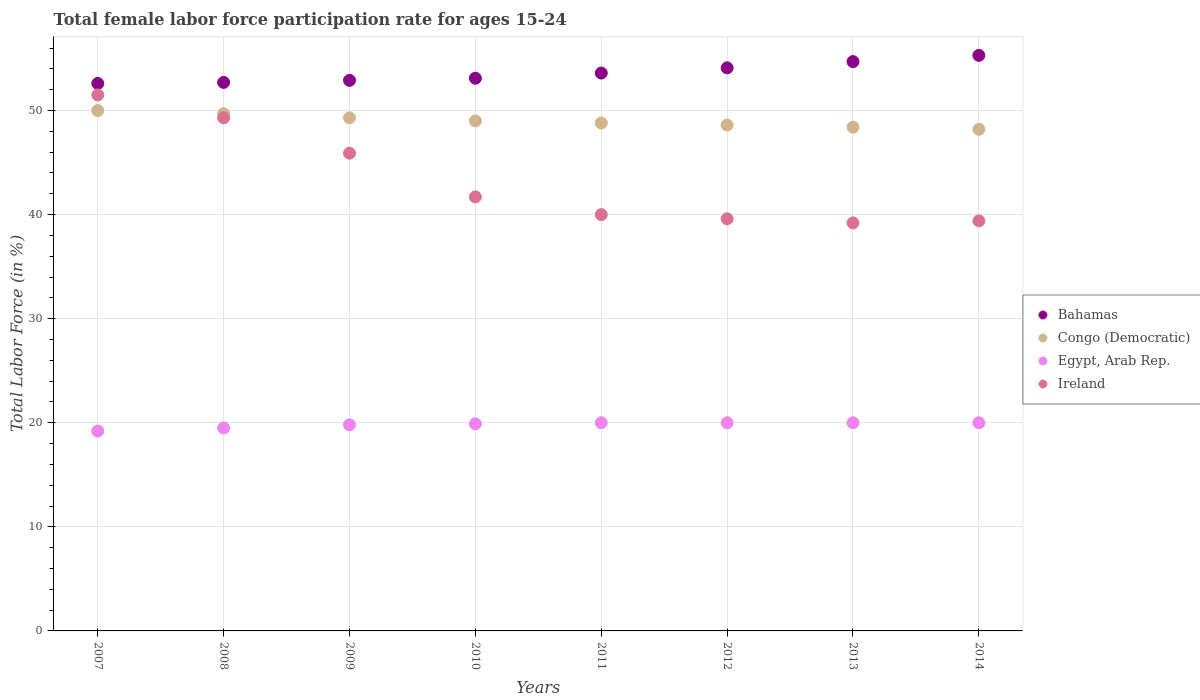What is the female labor force participation rate in Ireland in 2008?
Your response must be concise. 49.3. Across all years, what is the minimum female labor force participation rate in Bahamas?
Offer a very short reply. 52.6. What is the total female labor force participation rate in Bahamas in the graph?
Your answer should be very brief. 429. What is the difference between the female labor force participation rate in Congo (Democratic) in 2009 and that in 2014?
Your answer should be very brief. 1.1. What is the difference between the female labor force participation rate in Congo (Democratic) in 2011 and the female labor force participation rate in Egypt, Arab Rep. in 2008?
Give a very brief answer. 29.3. What is the average female labor force participation rate in Egypt, Arab Rep. per year?
Offer a very short reply. 19.8. In the year 2010, what is the difference between the female labor force participation rate in Bahamas and female labor force participation rate in Congo (Democratic)?
Keep it short and to the point. 4.1. In how many years, is the female labor force participation rate in Ireland greater than 28 %?
Provide a short and direct response. 8. What is the ratio of the female labor force participation rate in Egypt, Arab Rep. in 2009 to that in 2011?
Offer a terse response. 0.99. What is the difference between the highest and the second highest female labor force participation rate in Ireland?
Offer a very short reply. 2.2. What is the difference between the highest and the lowest female labor force participation rate in Egypt, Arab Rep.?
Offer a terse response. 0.8. Is it the case that in every year, the sum of the female labor force participation rate in Bahamas and female labor force participation rate in Egypt, Arab Rep.  is greater than the sum of female labor force participation rate in Congo (Democratic) and female labor force participation rate in Ireland?
Offer a terse response. No. Is it the case that in every year, the sum of the female labor force participation rate in Egypt, Arab Rep. and female labor force participation rate in Ireland  is greater than the female labor force participation rate in Bahamas?
Your answer should be very brief. Yes. Are the values on the major ticks of Y-axis written in scientific E-notation?
Ensure brevity in your answer.  No. What is the title of the graph?
Your response must be concise. Total female labor force participation rate for ages 15-24. What is the label or title of the X-axis?
Ensure brevity in your answer.  Years. What is the label or title of the Y-axis?
Your answer should be compact. Total Labor Force (in %). What is the Total Labor Force (in %) of Bahamas in 2007?
Make the answer very short. 52.6. What is the Total Labor Force (in %) in Egypt, Arab Rep. in 2007?
Keep it short and to the point. 19.2. What is the Total Labor Force (in %) of Ireland in 2007?
Your answer should be compact. 51.5. What is the Total Labor Force (in %) of Bahamas in 2008?
Your answer should be compact. 52.7. What is the Total Labor Force (in %) of Congo (Democratic) in 2008?
Offer a very short reply. 49.7. What is the Total Labor Force (in %) in Ireland in 2008?
Ensure brevity in your answer.  49.3. What is the Total Labor Force (in %) of Bahamas in 2009?
Provide a succinct answer. 52.9. What is the Total Labor Force (in %) of Congo (Democratic) in 2009?
Your answer should be compact. 49.3. What is the Total Labor Force (in %) in Egypt, Arab Rep. in 2009?
Your answer should be compact. 19.8. What is the Total Labor Force (in %) in Ireland in 2009?
Your answer should be compact. 45.9. What is the Total Labor Force (in %) in Bahamas in 2010?
Your answer should be compact. 53.1. What is the Total Labor Force (in %) of Egypt, Arab Rep. in 2010?
Make the answer very short. 19.9. What is the Total Labor Force (in %) in Ireland in 2010?
Make the answer very short. 41.7. What is the Total Labor Force (in %) of Bahamas in 2011?
Provide a succinct answer. 53.6. What is the Total Labor Force (in %) of Congo (Democratic) in 2011?
Give a very brief answer. 48.8. What is the Total Labor Force (in %) of Egypt, Arab Rep. in 2011?
Give a very brief answer. 20. What is the Total Labor Force (in %) of Ireland in 2011?
Give a very brief answer. 40. What is the Total Labor Force (in %) of Bahamas in 2012?
Ensure brevity in your answer.  54.1. What is the Total Labor Force (in %) in Congo (Democratic) in 2012?
Your response must be concise. 48.6. What is the Total Labor Force (in %) of Ireland in 2012?
Make the answer very short. 39.6. What is the Total Labor Force (in %) of Bahamas in 2013?
Give a very brief answer. 54.7. What is the Total Labor Force (in %) of Congo (Democratic) in 2013?
Ensure brevity in your answer.  48.4. What is the Total Labor Force (in %) in Egypt, Arab Rep. in 2013?
Make the answer very short. 20. What is the Total Labor Force (in %) in Ireland in 2013?
Keep it short and to the point. 39.2. What is the Total Labor Force (in %) of Bahamas in 2014?
Give a very brief answer. 55.3. What is the Total Labor Force (in %) of Congo (Democratic) in 2014?
Make the answer very short. 48.2. What is the Total Labor Force (in %) of Egypt, Arab Rep. in 2014?
Provide a succinct answer. 20. What is the Total Labor Force (in %) of Ireland in 2014?
Offer a terse response. 39.4. Across all years, what is the maximum Total Labor Force (in %) of Bahamas?
Provide a succinct answer. 55.3. Across all years, what is the maximum Total Labor Force (in %) in Ireland?
Your answer should be compact. 51.5. Across all years, what is the minimum Total Labor Force (in %) of Bahamas?
Provide a short and direct response. 52.6. Across all years, what is the minimum Total Labor Force (in %) of Congo (Democratic)?
Your answer should be compact. 48.2. Across all years, what is the minimum Total Labor Force (in %) in Egypt, Arab Rep.?
Your answer should be very brief. 19.2. Across all years, what is the minimum Total Labor Force (in %) in Ireland?
Make the answer very short. 39.2. What is the total Total Labor Force (in %) of Bahamas in the graph?
Keep it short and to the point. 429. What is the total Total Labor Force (in %) in Congo (Democratic) in the graph?
Offer a terse response. 392. What is the total Total Labor Force (in %) of Egypt, Arab Rep. in the graph?
Keep it short and to the point. 158.4. What is the total Total Labor Force (in %) in Ireland in the graph?
Your answer should be very brief. 346.6. What is the difference between the Total Labor Force (in %) in Ireland in 2007 and that in 2008?
Offer a terse response. 2.2. What is the difference between the Total Labor Force (in %) of Bahamas in 2007 and that in 2009?
Give a very brief answer. -0.3. What is the difference between the Total Labor Force (in %) of Ireland in 2007 and that in 2009?
Keep it short and to the point. 5.6. What is the difference between the Total Labor Force (in %) in Bahamas in 2007 and that in 2010?
Provide a succinct answer. -0.5. What is the difference between the Total Labor Force (in %) of Egypt, Arab Rep. in 2007 and that in 2010?
Keep it short and to the point. -0.7. What is the difference between the Total Labor Force (in %) of Bahamas in 2007 and that in 2011?
Your answer should be compact. -1. What is the difference between the Total Labor Force (in %) of Congo (Democratic) in 2007 and that in 2011?
Your response must be concise. 1.2. What is the difference between the Total Labor Force (in %) in Congo (Democratic) in 2007 and that in 2012?
Ensure brevity in your answer.  1.4. What is the difference between the Total Labor Force (in %) in Egypt, Arab Rep. in 2007 and that in 2012?
Offer a very short reply. -0.8. What is the difference between the Total Labor Force (in %) in Bahamas in 2007 and that in 2013?
Ensure brevity in your answer.  -2.1. What is the difference between the Total Labor Force (in %) of Egypt, Arab Rep. in 2007 and that in 2013?
Your answer should be compact. -0.8. What is the difference between the Total Labor Force (in %) of Bahamas in 2007 and that in 2014?
Your answer should be compact. -2.7. What is the difference between the Total Labor Force (in %) in Egypt, Arab Rep. in 2007 and that in 2014?
Offer a terse response. -0.8. What is the difference between the Total Labor Force (in %) in Ireland in 2007 and that in 2014?
Provide a short and direct response. 12.1. What is the difference between the Total Labor Force (in %) of Congo (Democratic) in 2008 and that in 2009?
Ensure brevity in your answer.  0.4. What is the difference between the Total Labor Force (in %) in Egypt, Arab Rep. in 2008 and that in 2009?
Offer a very short reply. -0.3. What is the difference between the Total Labor Force (in %) of Ireland in 2008 and that in 2009?
Your answer should be very brief. 3.4. What is the difference between the Total Labor Force (in %) in Ireland in 2008 and that in 2010?
Ensure brevity in your answer.  7.6. What is the difference between the Total Labor Force (in %) of Bahamas in 2008 and that in 2011?
Keep it short and to the point. -0.9. What is the difference between the Total Labor Force (in %) in Egypt, Arab Rep. in 2008 and that in 2011?
Provide a succinct answer. -0.5. What is the difference between the Total Labor Force (in %) of Bahamas in 2008 and that in 2013?
Your answer should be compact. -2. What is the difference between the Total Labor Force (in %) in Congo (Democratic) in 2008 and that in 2013?
Your answer should be very brief. 1.3. What is the difference between the Total Labor Force (in %) in Egypt, Arab Rep. in 2008 and that in 2013?
Offer a very short reply. -0.5. What is the difference between the Total Labor Force (in %) in Ireland in 2008 and that in 2013?
Your response must be concise. 10.1. What is the difference between the Total Labor Force (in %) in Egypt, Arab Rep. in 2008 and that in 2014?
Provide a succinct answer. -0.5. What is the difference between the Total Labor Force (in %) of Ireland in 2008 and that in 2014?
Provide a succinct answer. 9.9. What is the difference between the Total Labor Force (in %) in Bahamas in 2009 and that in 2010?
Your answer should be very brief. -0.2. What is the difference between the Total Labor Force (in %) in Congo (Democratic) in 2009 and that in 2010?
Your answer should be compact. 0.3. What is the difference between the Total Labor Force (in %) of Egypt, Arab Rep. in 2009 and that in 2010?
Ensure brevity in your answer.  -0.1. What is the difference between the Total Labor Force (in %) of Ireland in 2009 and that in 2010?
Provide a succinct answer. 4.2. What is the difference between the Total Labor Force (in %) in Bahamas in 2009 and that in 2011?
Make the answer very short. -0.7. What is the difference between the Total Labor Force (in %) in Congo (Democratic) in 2009 and that in 2012?
Ensure brevity in your answer.  0.7. What is the difference between the Total Labor Force (in %) in Bahamas in 2009 and that in 2013?
Your answer should be compact. -1.8. What is the difference between the Total Labor Force (in %) in Congo (Democratic) in 2009 and that in 2013?
Your answer should be very brief. 0.9. What is the difference between the Total Labor Force (in %) in Bahamas in 2009 and that in 2014?
Your response must be concise. -2.4. What is the difference between the Total Labor Force (in %) in Congo (Democratic) in 2009 and that in 2014?
Provide a short and direct response. 1.1. What is the difference between the Total Labor Force (in %) in Ireland in 2009 and that in 2014?
Ensure brevity in your answer.  6.5. What is the difference between the Total Labor Force (in %) in Bahamas in 2010 and that in 2011?
Your answer should be very brief. -0.5. What is the difference between the Total Labor Force (in %) of Congo (Democratic) in 2010 and that in 2011?
Provide a short and direct response. 0.2. What is the difference between the Total Labor Force (in %) of Egypt, Arab Rep. in 2010 and that in 2011?
Ensure brevity in your answer.  -0.1. What is the difference between the Total Labor Force (in %) of Ireland in 2010 and that in 2011?
Give a very brief answer. 1.7. What is the difference between the Total Labor Force (in %) of Bahamas in 2010 and that in 2012?
Your response must be concise. -1. What is the difference between the Total Labor Force (in %) of Congo (Democratic) in 2010 and that in 2012?
Ensure brevity in your answer.  0.4. What is the difference between the Total Labor Force (in %) of Egypt, Arab Rep. in 2010 and that in 2012?
Your answer should be very brief. -0.1. What is the difference between the Total Labor Force (in %) in Ireland in 2010 and that in 2012?
Give a very brief answer. 2.1. What is the difference between the Total Labor Force (in %) of Bahamas in 2010 and that in 2013?
Provide a short and direct response. -1.6. What is the difference between the Total Labor Force (in %) in Congo (Democratic) in 2010 and that in 2013?
Ensure brevity in your answer.  0.6. What is the difference between the Total Labor Force (in %) of Ireland in 2010 and that in 2013?
Provide a succinct answer. 2.5. What is the difference between the Total Labor Force (in %) in Congo (Democratic) in 2010 and that in 2014?
Your response must be concise. 0.8. What is the difference between the Total Labor Force (in %) of Egypt, Arab Rep. in 2010 and that in 2014?
Ensure brevity in your answer.  -0.1. What is the difference between the Total Labor Force (in %) in Ireland in 2010 and that in 2014?
Provide a succinct answer. 2.3. What is the difference between the Total Labor Force (in %) of Congo (Democratic) in 2011 and that in 2012?
Ensure brevity in your answer.  0.2. What is the difference between the Total Labor Force (in %) of Congo (Democratic) in 2011 and that in 2013?
Your response must be concise. 0.4. What is the difference between the Total Labor Force (in %) of Egypt, Arab Rep. in 2011 and that in 2013?
Offer a very short reply. 0. What is the difference between the Total Labor Force (in %) of Ireland in 2011 and that in 2013?
Make the answer very short. 0.8. What is the difference between the Total Labor Force (in %) in Egypt, Arab Rep. in 2011 and that in 2014?
Keep it short and to the point. 0. What is the difference between the Total Labor Force (in %) in Bahamas in 2012 and that in 2013?
Make the answer very short. -0.6. What is the difference between the Total Labor Force (in %) in Egypt, Arab Rep. in 2012 and that in 2013?
Your response must be concise. 0. What is the difference between the Total Labor Force (in %) in Ireland in 2012 and that in 2013?
Offer a terse response. 0.4. What is the difference between the Total Labor Force (in %) of Congo (Democratic) in 2012 and that in 2014?
Give a very brief answer. 0.4. What is the difference between the Total Labor Force (in %) in Ireland in 2012 and that in 2014?
Provide a short and direct response. 0.2. What is the difference between the Total Labor Force (in %) in Congo (Democratic) in 2013 and that in 2014?
Make the answer very short. 0.2. What is the difference between the Total Labor Force (in %) of Egypt, Arab Rep. in 2013 and that in 2014?
Make the answer very short. 0. What is the difference between the Total Labor Force (in %) in Ireland in 2013 and that in 2014?
Provide a succinct answer. -0.2. What is the difference between the Total Labor Force (in %) of Bahamas in 2007 and the Total Labor Force (in %) of Congo (Democratic) in 2008?
Make the answer very short. 2.9. What is the difference between the Total Labor Force (in %) in Bahamas in 2007 and the Total Labor Force (in %) in Egypt, Arab Rep. in 2008?
Keep it short and to the point. 33.1. What is the difference between the Total Labor Force (in %) in Congo (Democratic) in 2007 and the Total Labor Force (in %) in Egypt, Arab Rep. in 2008?
Your answer should be very brief. 30.5. What is the difference between the Total Labor Force (in %) in Egypt, Arab Rep. in 2007 and the Total Labor Force (in %) in Ireland in 2008?
Keep it short and to the point. -30.1. What is the difference between the Total Labor Force (in %) of Bahamas in 2007 and the Total Labor Force (in %) of Congo (Democratic) in 2009?
Your answer should be very brief. 3.3. What is the difference between the Total Labor Force (in %) of Bahamas in 2007 and the Total Labor Force (in %) of Egypt, Arab Rep. in 2009?
Your answer should be very brief. 32.8. What is the difference between the Total Labor Force (in %) of Bahamas in 2007 and the Total Labor Force (in %) of Ireland in 2009?
Ensure brevity in your answer.  6.7. What is the difference between the Total Labor Force (in %) in Congo (Democratic) in 2007 and the Total Labor Force (in %) in Egypt, Arab Rep. in 2009?
Your answer should be compact. 30.2. What is the difference between the Total Labor Force (in %) in Egypt, Arab Rep. in 2007 and the Total Labor Force (in %) in Ireland in 2009?
Offer a very short reply. -26.7. What is the difference between the Total Labor Force (in %) in Bahamas in 2007 and the Total Labor Force (in %) in Egypt, Arab Rep. in 2010?
Make the answer very short. 32.7. What is the difference between the Total Labor Force (in %) of Congo (Democratic) in 2007 and the Total Labor Force (in %) of Egypt, Arab Rep. in 2010?
Your answer should be compact. 30.1. What is the difference between the Total Labor Force (in %) of Congo (Democratic) in 2007 and the Total Labor Force (in %) of Ireland in 2010?
Your response must be concise. 8.3. What is the difference between the Total Labor Force (in %) in Egypt, Arab Rep. in 2007 and the Total Labor Force (in %) in Ireland in 2010?
Offer a very short reply. -22.5. What is the difference between the Total Labor Force (in %) in Bahamas in 2007 and the Total Labor Force (in %) in Egypt, Arab Rep. in 2011?
Make the answer very short. 32.6. What is the difference between the Total Labor Force (in %) in Egypt, Arab Rep. in 2007 and the Total Labor Force (in %) in Ireland in 2011?
Offer a terse response. -20.8. What is the difference between the Total Labor Force (in %) in Bahamas in 2007 and the Total Labor Force (in %) in Egypt, Arab Rep. in 2012?
Ensure brevity in your answer.  32.6. What is the difference between the Total Labor Force (in %) in Bahamas in 2007 and the Total Labor Force (in %) in Ireland in 2012?
Ensure brevity in your answer.  13. What is the difference between the Total Labor Force (in %) in Egypt, Arab Rep. in 2007 and the Total Labor Force (in %) in Ireland in 2012?
Your response must be concise. -20.4. What is the difference between the Total Labor Force (in %) of Bahamas in 2007 and the Total Labor Force (in %) of Congo (Democratic) in 2013?
Provide a succinct answer. 4.2. What is the difference between the Total Labor Force (in %) of Bahamas in 2007 and the Total Labor Force (in %) of Egypt, Arab Rep. in 2013?
Offer a very short reply. 32.6. What is the difference between the Total Labor Force (in %) in Bahamas in 2007 and the Total Labor Force (in %) in Ireland in 2013?
Offer a very short reply. 13.4. What is the difference between the Total Labor Force (in %) of Bahamas in 2007 and the Total Labor Force (in %) of Egypt, Arab Rep. in 2014?
Ensure brevity in your answer.  32.6. What is the difference between the Total Labor Force (in %) in Egypt, Arab Rep. in 2007 and the Total Labor Force (in %) in Ireland in 2014?
Your answer should be compact. -20.2. What is the difference between the Total Labor Force (in %) in Bahamas in 2008 and the Total Labor Force (in %) in Egypt, Arab Rep. in 2009?
Provide a succinct answer. 32.9. What is the difference between the Total Labor Force (in %) of Bahamas in 2008 and the Total Labor Force (in %) of Ireland in 2009?
Keep it short and to the point. 6.8. What is the difference between the Total Labor Force (in %) of Congo (Democratic) in 2008 and the Total Labor Force (in %) of Egypt, Arab Rep. in 2009?
Provide a short and direct response. 29.9. What is the difference between the Total Labor Force (in %) in Egypt, Arab Rep. in 2008 and the Total Labor Force (in %) in Ireland in 2009?
Provide a short and direct response. -26.4. What is the difference between the Total Labor Force (in %) in Bahamas in 2008 and the Total Labor Force (in %) in Congo (Democratic) in 2010?
Provide a succinct answer. 3.7. What is the difference between the Total Labor Force (in %) of Bahamas in 2008 and the Total Labor Force (in %) of Egypt, Arab Rep. in 2010?
Give a very brief answer. 32.8. What is the difference between the Total Labor Force (in %) of Bahamas in 2008 and the Total Labor Force (in %) of Ireland in 2010?
Ensure brevity in your answer.  11. What is the difference between the Total Labor Force (in %) of Congo (Democratic) in 2008 and the Total Labor Force (in %) of Egypt, Arab Rep. in 2010?
Your answer should be very brief. 29.8. What is the difference between the Total Labor Force (in %) of Congo (Democratic) in 2008 and the Total Labor Force (in %) of Ireland in 2010?
Make the answer very short. 8. What is the difference between the Total Labor Force (in %) of Egypt, Arab Rep. in 2008 and the Total Labor Force (in %) of Ireland in 2010?
Make the answer very short. -22.2. What is the difference between the Total Labor Force (in %) of Bahamas in 2008 and the Total Labor Force (in %) of Congo (Democratic) in 2011?
Offer a terse response. 3.9. What is the difference between the Total Labor Force (in %) of Bahamas in 2008 and the Total Labor Force (in %) of Egypt, Arab Rep. in 2011?
Make the answer very short. 32.7. What is the difference between the Total Labor Force (in %) in Congo (Democratic) in 2008 and the Total Labor Force (in %) in Egypt, Arab Rep. in 2011?
Ensure brevity in your answer.  29.7. What is the difference between the Total Labor Force (in %) in Egypt, Arab Rep. in 2008 and the Total Labor Force (in %) in Ireland in 2011?
Offer a very short reply. -20.5. What is the difference between the Total Labor Force (in %) in Bahamas in 2008 and the Total Labor Force (in %) in Congo (Democratic) in 2012?
Provide a succinct answer. 4.1. What is the difference between the Total Labor Force (in %) in Bahamas in 2008 and the Total Labor Force (in %) in Egypt, Arab Rep. in 2012?
Your response must be concise. 32.7. What is the difference between the Total Labor Force (in %) in Bahamas in 2008 and the Total Labor Force (in %) in Ireland in 2012?
Offer a terse response. 13.1. What is the difference between the Total Labor Force (in %) of Congo (Democratic) in 2008 and the Total Labor Force (in %) of Egypt, Arab Rep. in 2012?
Ensure brevity in your answer.  29.7. What is the difference between the Total Labor Force (in %) in Egypt, Arab Rep. in 2008 and the Total Labor Force (in %) in Ireland in 2012?
Keep it short and to the point. -20.1. What is the difference between the Total Labor Force (in %) of Bahamas in 2008 and the Total Labor Force (in %) of Egypt, Arab Rep. in 2013?
Make the answer very short. 32.7. What is the difference between the Total Labor Force (in %) of Bahamas in 2008 and the Total Labor Force (in %) of Ireland in 2013?
Ensure brevity in your answer.  13.5. What is the difference between the Total Labor Force (in %) of Congo (Democratic) in 2008 and the Total Labor Force (in %) of Egypt, Arab Rep. in 2013?
Make the answer very short. 29.7. What is the difference between the Total Labor Force (in %) of Egypt, Arab Rep. in 2008 and the Total Labor Force (in %) of Ireland in 2013?
Your answer should be very brief. -19.7. What is the difference between the Total Labor Force (in %) of Bahamas in 2008 and the Total Labor Force (in %) of Egypt, Arab Rep. in 2014?
Provide a short and direct response. 32.7. What is the difference between the Total Labor Force (in %) in Bahamas in 2008 and the Total Labor Force (in %) in Ireland in 2014?
Offer a terse response. 13.3. What is the difference between the Total Labor Force (in %) of Congo (Democratic) in 2008 and the Total Labor Force (in %) of Egypt, Arab Rep. in 2014?
Offer a very short reply. 29.7. What is the difference between the Total Labor Force (in %) in Egypt, Arab Rep. in 2008 and the Total Labor Force (in %) in Ireland in 2014?
Your answer should be very brief. -19.9. What is the difference between the Total Labor Force (in %) in Bahamas in 2009 and the Total Labor Force (in %) in Ireland in 2010?
Provide a short and direct response. 11.2. What is the difference between the Total Labor Force (in %) of Congo (Democratic) in 2009 and the Total Labor Force (in %) of Egypt, Arab Rep. in 2010?
Ensure brevity in your answer.  29.4. What is the difference between the Total Labor Force (in %) in Congo (Democratic) in 2009 and the Total Labor Force (in %) in Ireland in 2010?
Provide a short and direct response. 7.6. What is the difference between the Total Labor Force (in %) of Egypt, Arab Rep. in 2009 and the Total Labor Force (in %) of Ireland in 2010?
Give a very brief answer. -21.9. What is the difference between the Total Labor Force (in %) of Bahamas in 2009 and the Total Labor Force (in %) of Egypt, Arab Rep. in 2011?
Give a very brief answer. 32.9. What is the difference between the Total Labor Force (in %) of Congo (Democratic) in 2009 and the Total Labor Force (in %) of Egypt, Arab Rep. in 2011?
Provide a succinct answer. 29.3. What is the difference between the Total Labor Force (in %) of Congo (Democratic) in 2009 and the Total Labor Force (in %) of Ireland in 2011?
Provide a succinct answer. 9.3. What is the difference between the Total Labor Force (in %) in Egypt, Arab Rep. in 2009 and the Total Labor Force (in %) in Ireland in 2011?
Offer a terse response. -20.2. What is the difference between the Total Labor Force (in %) in Bahamas in 2009 and the Total Labor Force (in %) in Egypt, Arab Rep. in 2012?
Provide a short and direct response. 32.9. What is the difference between the Total Labor Force (in %) of Congo (Democratic) in 2009 and the Total Labor Force (in %) of Egypt, Arab Rep. in 2012?
Your answer should be very brief. 29.3. What is the difference between the Total Labor Force (in %) of Congo (Democratic) in 2009 and the Total Labor Force (in %) of Ireland in 2012?
Your answer should be very brief. 9.7. What is the difference between the Total Labor Force (in %) of Egypt, Arab Rep. in 2009 and the Total Labor Force (in %) of Ireland in 2012?
Provide a short and direct response. -19.8. What is the difference between the Total Labor Force (in %) in Bahamas in 2009 and the Total Labor Force (in %) in Egypt, Arab Rep. in 2013?
Your answer should be very brief. 32.9. What is the difference between the Total Labor Force (in %) of Congo (Democratic) in 2009 and the Total Labor Force (in %) of Egypt, Arab Rep. in 2013?
Your answer should be very brief. 29.3. What is the difference between the Total Labor Force (in %) in Egypt, Arab Rep. in 2009 and the Total Labor Force (in %) in Ireland in 2013?
Provide a short and direct response. -19.4. What is the difference between the Total Labor Force (in %) in Bahamas in 2009 and the Total Labor Force (in %) in Congo (Democratic) in 2014?
Provide a succinct answer. 4.7. What is the difference between the Total Labor Force (in %) of Bahamas in 2009 and the Total Labor Force (in %) of Egypt, Arab Rep. in 2014?
Your answer should be compact. 32.9. What is the difference between the Total Labor Force (in %) in Bahamas in 2009 and the Total Labor Force (in %) in Ireland in 2014?
Your response must be concise. 13.5. What is the difference between the Total Labor Force (in %) in Congo (Democratic) in 2009 and the Total Labor Force (in %) in Egypt, Arab Rep. in 2014?
Your answer should be very brief. 29.3. What is the difference between the Total Labor Force (in %) in Egypt, Arab Rep. in 2009 and the Total Labor Force (in %) in Ireland in 2014?
Give a very brief answer. -19.6. What is the difference between the Total Labor Force (in %) of Bahamas in 2010 and the Total Labor Force (in %) of Egypt, Arab Rep. in 2011?
Keep it short and to the point. 33.1. What is the difference between the Total Labor Force (in %) in Congo (Democratic) in 2010 and the Total Labor Force (in %) in Ireland in 2011?
Your response must be concise. 9. What is the difference between the Total Labor Force (in %) in Egypt, Arab Rep. in 2010 and the Total Labor Force (in %) in Ireland in 2011?
Provide a succinct answer. -20.1. What is the difference between the Total Labor Force (in %) of Bahamas in 2010 and the Total Labor Force (in %) of Egypt, Arab Rep. in 2012?
Provide a succinct answer. 33.1. What is the difference between the Total Labor Force (in %) of Bahamas in 2010 and the Total Labor Force (in %) of Ireland in 2012?
Offer a terse response. 13.5. What is the difference between the Total Labor Force (in %) of Congo (Democratic) in 2010 and the Total Labor Force (in %) of Egypt, Arab Rep. in 2012?
Make the answer very short. 29. What is the difference between the Total Labor Force (in %) in Congo (Democratic) in 2010 and the Total Labor Force (in %) in Ireland in 2012?
Provide a succinct answer. 9.4. What is the difference between the Total Labor Force (in %) in Egypt, Arab Rep. in 2010 and the Total Labor Force (in %) in Ireland in 2012?
Offer a terse response. -19.7. What is the difference between the Total Labor Force (in %) of Bahamas in 2010 and the Total Labor Force (in %) of Congo (Democratic) in 2013?
Keep it short and to the point. 4.7. What is the difference between the Total Labor Force (in %) of Bahamas in 2010 and the Total Labor Force (in %) of Egypt, Arab Rep. in 2013?
Your response must be concise. 33.1. What is the difference between the Total Labor Force (in %) in Bahamas in 2010 and the Total Labor Force (in %) in Ireland in 2013?
Your answer should be compact. 13.9. What is the difference between the Total Labor Force (in %) in Congo (Democratic) in 2010 and the Total Labor Force (in %) in Egypt, Arab Rep. in 2013?
Offer a very short reply. 29. What is the difference between the Total Labor Force (in %) in Egypt, Arab Rep. in 2010 and the Total Labor Force (in %) in Ireland in 2013?
Your answer should be compact. -19.3. What is the difference between the Total Labor Force (in %) in Bahamas in 2010 and the Total Labor Force (in %) in Egypt, Arab Rep. in 2014?
Offer a terse response. 33.1. What is the difference between the Total Labor Force (in %) of Bahamas in 2010 and the Total Labor Force (in %) of Ireland in 2014?
Provide a short and direct response. 13.7. What is the difference between the Total Labor Force (in %) of Congo (Democratic) in 2010 and the Total Labor Force (in %) of Ireland in 2014?
Provide a short and direct response. 9.6. What is the difference between the Total Labor Force (in %) of Egypt, Arab Rep. in 2010 and the Total Labor Force (in %) of Ireland in 2014?
Your answer should be compact. -19.5. What is the difference between the Total Labor Force (in %) of Bahamas in 2011 and the Total Labor Force (in %) of Egypt, Arab Rep. in 2012?
Give a very brief answer. 33.6. What is the difference between the Total Labor Force (in %) of Bahamas in 2011 and the Total Labor Force (in %) of Ireland in 2012?
Provide a succinct answer. 14. What is the difference between the Total Labor Force (in %) in Congo (Democratic) in 2011 and the Total Labor Force (in %) in Egypt, Arab Rep. in 2012?
Make the answer very short. 28.8. What is the difference between the Total Labor Force (in %) in Congo (Democratic) in 2011 and the Total Labor Force (in %) in Ireland in 2012?
Your answer should be compact. 9.2. What is the difference between the Total Labor Force (in %) in Egypt, Arab Rep. in 2011 and the Total Labor Force (in %) in Ireland in 2012?
Keep it short and to the point. -19.6. What is the difference between the Total Labor Force (in %) in Bahamas in 2011 and the Total Labor Force (in %) in Egypt, Arab Rep. in 2013?
Offer a terse response. 33.6. What is the difference between the Total Labor Force (in %) in Bahamas in 2011 and the Total Labor Force (in %) in Ireland in 2013?
Give a very brief answer. 14.4. What is the difference between the Total Labor Force (in %) in Congo (Democratic) in 2011 and the Total Labor Force (in %) in Egypt, Arab Rep. in 2013?
Offer a very short reply. 28.8. What is the difference between the Total Labor Force (in %) of Egypt, Arab Rep. in 2011 and the Total Labor Force (in %) of Ireland in 2013?
Offer a very short reply. -19.2. What is the difference between the Total Labor Force (in %) in Bahamas in 2011 and the Total Labor Force (in %) in Congo (Democratic) in 2014?
Ensure brevity in your answer.  5.4. What is the difference between the Total Labor Force (in %) in Bahamas in 2011 and the Total Labor Force (in %) in Egypt, Arab Rep. in 2014?
Give a very brief answer. 33.6. What is the difference between the Total Labor Force (in %) of Bahamas in 2011 and the Total Labor Force (in %) of Ireland in 2014?
Provide a succinct answer. 14.2. What is the difference between the Total Labor Force (in %) in Congo (Democratic) in 2011 and the Total Labor Force (in %) in Egypt, Arab Rep. in 2014?
Make the answer very short. 28.8. What is the difference between the Total Labor Force (in %) in Congo (Democratic) in 2011 and the Total Labor Force (in %) in Ireland in 2014?
Your response must be concise. 9.4. What is the difference between the Total Labor Force (in %) in Egypt, Arab Rep. in 2011 and the Total Labor Force (in %) in Ireland in 2014?
Keep it short and to the point. -19.4. What is the difference between the Total Labor Force (in %) in Bahamas in 2012 and the Total Labor Force (in %) in Egypt, Arab Rep. in 2013?
Your answer should be compact. 34.1. What is the difference between the Total Labor Force (in %) of Congo (Democratic) in 2012 and the Total Labor Force (in %) of Egypt, Arab Rep. in 2013?
Your answer should be compact. 28.6. What is the difference between the Total Labor Force (in %) of Congo (Democratic) in 2012 and the Total Labor Force (in %) of Ireland in 2013?
Keep it short and to the point. 9.4. What is the difference between the Total Labor Force (in %) in Egypt, Arab Rep. in 2012 and the Total Labor Force (in %) in Ireland in 2013?
Give a very brief answer. -19.2. What is the difference between the Total Labor Force (in %) in Bahamas in 2012 and the Total Labor Force (in %) in Congo (Democratic) in 2014?
Offer a terse response. 5.9. What is the difference between the Total Labor Force (in %) of Bahamas in 2012 and the Total Labor Force (in %) of Egypt, Arab Rep. in 2014?
Provide a short and direct response. 34.1. What is the difference between the Total Labor Force (in %) in Congo (Democratic) in 2012 and the Total Labor Force (in %) in Egypt, Arab Rep. in 2014?
Offer a very short reply. 28.6. What is the difference between the Total Labor Force (in %) of Congo (Democratic) in 2012 and the Total Labor Force (in %) of Ireland in 2014?
Your response must be concise. 9.2. What is the difference between the Total Labor Force (in %) in Egypt, Arab Rep. in 2012 and the Total Labor Force (in %) in Ireland in 2014?
Ensure brevity in your answer.  -19.4. What is the difference between the Total Labor Force (in %) in Bahamas in 2013 and the Total Labor Force (in %) in Egypt, Arab Rep. in 2014?
Your answer should be very brief. 34.7. What is the difference between the Total Labor Force (in %) in Bahamas in 2013 and the Total Labor Force (in %) in Ireland in 2014?
Your answer should be compact. 15.3. What is the difference between the Total Labor Force (in %) in Congo (Democratic) in 2013 and the Total Labor Force (in %) in Egypt, Arab Rep. in 2014?
Ensure brevity in your answer.  28.4. What is the difference between the Total Labor Force (in %) in Congo (Democratic) in 2013 and the Total Labor Force (in %) in Ireland in 2014?
Your answer should be compact. 9. What is the difference between the Total Labor Force (in %) of Egypt, Arab Rep. in 2013 and the Total Labor Force (in %) of Ireland in 2014?
Provide a short and direct response. -19.4. What is the average Total Labor Force (in %) of Bahamas per year?
Offer a very short reply. 53.62. What is the average Total Labor Force (in %) in Congo (Democratic) per year?
Offer a terse response. 49. What is the average Total Labor Force (in %) in Egypt, Arab Rep. per year?
Offer a terse response. 19.8. What is the average Total Labor Force (in %) of Ireland per year?
Provide a short and direct response. 43.33. In the year 2007, what is the difference between the Total Labor Force (in %) in Bahamas and Total Labor Force (in %) in Egypt, Arab Rep.?
Make the answer very short. 33.4. In the year 2007, what is the difference between the Total Labor Force (in %) in Bahamas and Total Labor Force (in %) in Ireland?
Your answer should be compact. 1.1. In the year 2007, what is the difference between the Total Labor Force (in %) in Congo (Democratic) and Total Labor Force (in %) in Egypt, Arab Rep.?
Keep it short and to the point. 30.8. In the year 2007, what is the difference between the Total Labor Force (in %) in Congo (Democratic) and Total Labor Force (in %) in Ireland?
Provide a succinct answer. -1.5. In the year 2007, what is the difference between the Total Labor Force (in %) of Egypt, Arab Rep. and Total Labor Force (in %) of Ireland?
Provide a succinct answer. -32.3. In the year 2008, what is the difference between the Total Labor Force (in %) in Bahamas and Total Labor Force (in %) in Egypt, Arab Rep.?
Offer a terse response. 33.2. In the year 2008, what is the difference between the Total Labor Force (in %) of Bahamas and Total Labor Force (in %) of Ireland?
Offer a terse response. 3.4. In the year 2008, what is the difference between the Total Labor Force (in %) in Congo (Democratic) and Total Labor Force (in %) in Egypt, Arab Rep.?
Offer a terse response. 30.2. In the year 2008, what is the difference between the Total Labor Force (in %) in Congo (Democratic) and Total Labor Force (in %) in Ireland?
Your answer should be very brief. 0.4. In the year 2008, what is the difference between the Total Labor Force (in %) in Egypt, Arab Rep. and Total Labor Force (in %) in Ireland?
Ensure brevity in your answer.  -29.8. In the year 2009, what is the difference between the Total Labor Force (in %) in Bahamas and Total Labor Force (in %) in Egypt, Arab Rep.?
Offer a very short reply. 33.1. In the year 2009, what is the difference between the Total Labor Force (in %) in Congo (Democratic) and Total Labor Force (in %) in Egypt, Arab Rep.?
Your answer should be compact. 29.5. In the year 2009, what is the difference between the Total Labor Force (in %) in Congo (Democratic) and Total Labor Force (in %) in Ireland?
Make the answer very short. 3.4. In the year 2009, what is the difference between the Total Labor Force (in %) in Egypt, Arab Rep. and Total Labor Force (in %) in Ireland?
Keep it short and to the point. -26.1. In the year 2010, what is the difference between the Total Labor Force (in %) in Bahamas and Total Labor Force (in %) in Egypt, Arab Rep.?
Your answer should be compact. 33.2. In the year 2010, what is the difference between the Total Labor Force (in %) in Bahamas and Total Labor Force (in %) in Ireland?
Your response must be concise. 11.4. In the year 2010, what is the difference between the Total Labor Force (in %) in Congo (Democratic) and Total Labor Force (in %) in Egypt, Arab Rep.?
Offer a very short reply. 29.1. In the year 2010, what is the difference between the Total Labor Force (in %) of Egypt, Arab Rep. and Total Labor Force (in %) of Ireland?
Keep it short and to the point. -21.8. In the year 2011, what is the difference between the Total Labor Force (in %) in Bahamas and Total Labor Force (in %) in Congo (Democratic)?
Provide a short and direct response. 4.8. In the year 2011, what is the difference between the Total Labor Force (in %) in Bahamas and Total Labor Force (in %) in Egypt, Arab Rep.?
Your answer should be very brief. 33.6. In the year 2011, what is the difference between the Total Labor Force (in %) of Congo (Democratic) and Total Labor Force (in %) of Egypt, Arab Rep.?
Provide a succinct answer. 28.8. In the year 2011, what is the difference between the Total Labor Force (in %) in Egypt, Arab Rep. and Total Labor Force (in %) in Ireland?
Make the answer very short. -20. In the year 2012, what is the difference between the Total Labor Force (in %) of Bahamas and Total Labor Force (in %) of Congo (Democratic)?
Provide a short and direct response. 5.5. In the year 2012, what is the difference between the Total Labor Force (in %) of Bahamas and Total Labor Force (in %) of Egypt, Arab Rep.?
Provide a succinct answer. 34.1. In the year 2012, what is the difference between the Total Labor Force (in %) in Bahamas and Total Labor Force (in %) in Ireland?
Keep it short and to the point. 14.5. In the year 2012, what is the difference between the Total Labor Force (in %) of Congo (Democratic) and Total Labor Force (in %) of Egypt, Arab Rep.?
Offer a very short reply. 28.6. In the year 2012, what is the difference between the Total Labor Force (in %) in Congo (Democratic) and Total Labor Force (in %) in Ireland?
Offer a terse response. 9. In the year 2012, what is the difference between the Total Labor Force (in %) in Egypt, Arab Rep. and Total Labor Force (in %) in Ireland?
Your response must be concise. -19.6. In the year 2013, what is the difference between the Total Labor Force (in %) of Bahamas and Total Labor Force (in %) of Egypt, Arab Rep.?
Provide a short and direct response. 34.7. In the year 2013, what is the difference between the Total Labor Force (in %) in Congo (Democratic) and Total Labor Force (in %) in Egypt, Arab Rep.?
Offer a very short reply. 28.4. In the year 2013, what is the difference between the Total Labor Force (in %) in Congo (Democratic) and Total Labor Force (in %) in Ireland?
Offer a very short reply. 9.2. In the year 2013, what is the difference between the Total Labor Force (in %) in Egypt, Arab Rep. and Total Labor Force (in %) in Ireland?
Ensure brevity in your answer.  -19.2. In the year 2014, what is the difference between the Total Labor Force (in %) in Bahamas and Total Labor Force (in %) in Egypt, Arab Rep.?
Offer a very short reply. 35.3. In the year 2014, what is the difference between the Total Labor Force (in %) in Bahamas and Total Labor Force (in %) in Ireland?
Your answer should be very brief. 15.9. In the year 2014, what is the difference between the Total Labor Force (in %) in Congo (Democratic) and Total Labor Force (in %) in Egypt, Arab Rep.?
Offer a very short reply. 28.2. In the year 2014, what is the difference between the Total Labor Force (in %) in Congo (Democratic) and Total Labor Force (in %) in Ireland?
Keep it short and to the point. 8.8. In the year 2014, what is the difference between the Total Labor Force (in %) of Egypt, Arab Rep. and Total Labor Force (in %) of Ireland?
Provide a succinct answer. -19.4. What is the ratio of the Total Labor Force (in %) in Egypt, Arab Rep. in 2007 to that in 2008?
Keep it short and to the point. 0.98. What is the ratio of the Total Labor Force (in %) of Ireland in 2007 to that in 2008?
Ensure brevity in your answer.  1.04. What is the ratio of the Total Labor Force (in %) in Congo (Democratic) in 2007 to that in 2009?
Ensure brevity in your answer.  1.01. What is the ratio of the Total Labor Force (in %) in Egypt, Arab Rep. in 2007 to that in 2009?
Provide a succinct answer. 0.97. What is the ratio of the Total Labor Force (in %) of Ireland in 2007 to that in 2009?
Give a very brief answer. 1.12. What is the ratio of the Total Labor Force (in %) in Bahamas in 2007 to that in 2010?
Provide a short and direct response. 0.99. What is the ratio of the Total Labor Force (in %) of Congo (Democratic) in 2007 to that in 2010?
Give a very brief answer. 1.02. What is the ratio of the Total Labor Force (in %) of Egypt, Arab Rep. in 2007 to that in 2010?
Keep it short and to the point. 0.96. What is the ratio of the Total Labor Force (in %) of Ireland in 2007 to that in 2010?
Offer a terse response. 1.24. What is the ratio of the Total Labor Force (in %) in Bahamas in 2007 to that in 2011?
Your response must be concise. 0.98. What is the ratio of the Total Labor Force (in %) in Congo (Democratic) in 2007 to that in 2011?
Your answer should be very brief. 1.02. What is the ratio of the Total Labor Force (in %) in Egypt, Arab Rep. in 2007 to that in 2011?
Give a very brief answer. 0.96. What is the ratio of the Total Labor Force (in %) of Ireland in 2007 to that in 2011?
Your answer should be very brief. 1.29. What is the ratio of the Total Labor Force (in %) in Bahamas in 2007 to that in 2012?
Offer a very short reply. 0.97. What is the ratio of the Total Labor Force (in %) in Congo (Democratic) in 2007 to that in 2012?
Give a very brief answer. 1.03. What is the ratio of the Total Labor Force (in %) of Ireland in 2007 to that in 2012?
Offer a terse response. 1.3. What is the ratio of the Total Labor Force (in %) in Bahamas in 2007 to that in 2013?
Your response must be concise. 0.96. What is the ratio of the Total Labor Force (in %) in Congo (Democratic) in 2007 to that in 2013?
Your answer should be very brief. 1.03. What is the ratio of the Total Labor Force (in %) in Ireland in 2007 to that in 2013?
Offer a very short reply. 1.31. What is the ratio of the Total Labor Force (in %) in Bahamas in 2007 to that in 2014?
Give a very brief answer. 0.95. What is the ratio of the Total Labor Force (in %) of Congo (Democratic) in 2007 to that in 2014?
Your answer should be compact. 1.04. What is the ratio of the Total Labor Force (in %) of Egypt, Arab Rep. in 2007 to that in 2014?
Keep it short and to the point. 0.96. What is the ratio of the Total Labor Force (in %) of Ireland in 2007 to that in 2014?
Make the answer very short. 1.31. What is the ratio of the Total Labor Force (in %) in Bahamas in 2008 to that in 2009?
Offer a terse response. 1. What is the ratio of the Total Labor Force (in %) in Egypt, Arab Rep. in 2008 to that in 2009?
Offer a very short reply. 0.98. What is the ratio of the Total Labor Force (in %) of Ireland in 2008 to that in 2009?
Your answer should be very brief. 1.07. What is the ratio of the Total Labor Force (in %) of Congo (Democratic) in 2008 to that in 2010?
Provide a short and direct response. 1.01. What is the ratio of the Total Labor Force (in %) of Egypt, Arab Rep. in 2008 to that in 2010?
Give a very brief answer. 0.98. What is the ratio of the Total Labor Force (in %) in Ireland in 2008 to that in 2010?
Ensure brevity in your answer.  1.18. What is the ratio of the Total Labor Force (in %) of Bahamas in 2008 to that in 2011?
Provide a short and direct response. 0.98. What is the ratio of the Total Labor Force (in %) of Congo (Democratic) in 2008 to that in 2011?
Offer a terse response. 1.02. What is the ratio of the Total Labor Force (in %) of Egypt, Arab Rep. in 2008 to that in 2011?
Provide a short and direct response. 0.97. What is the ratio of the Total Labor Force (in %) of Ireland in 2008 to that in 2011?
Offer a very short reply. 1.23. What is the ratio of the Total Labor Force (in %) of Bahamas in 2008 to that in 2012?
Provide a succinct answer. 0.97. What is the ratio of the Total Labor Force (in %) of Congo (Democratic) in 2008 to that in 2012?
Your answer should be very brief. 1.02. What is the ratio of the Total Labor Force (in %) of Egypt, Arab Rep. in 2008 to that in 2012?
Make the answer very short. 0.97. What is the ratio of the Total Labor Force (in %) in Ireland in 2008 to that in 2012?
Your answer should be very brief. 1.24. What is the ratio of the Total Labor Force (in %) in Bahamas in 2008 to that in 2013?
Offer a terse response. 0.96. What is the ratio of the Total Labor Force (in %) of Congo (Democratic) in 2008 to that in 2013?
Your response must be concise. 1.03. What is the ratio of the Total Labor Force (in %) of Egypt, Arab Rep. in 2008 to that in 2013?
Provide a succinct answer. 0.97. What is the ratio of the Total Labor Force (in %) in Ireland in 2008 to that in 2013?
Offer a very short reply. 1.26. What is the ratio of the Total Labor Force (in %) of Bahamas in 2008 to that in 2014?
Ensure brevity in your answer.  0.95. What is the ratio of the Total Labor Force (in %) of Congo (Democratic) in 2008 to that in 2014?
Your answer should be very brief. 1.03. What is the ratio of the Total Labor Force (in %) in Ireland in 2008 to that in 2014?
Your answer should be compact. 1.25. What is the ratio of the Total Labor Force (in %) of Bahamas in 2009 to that in 2010?
Keep it short and to the point. 1. What is the ratio of the Total Labor Force (in %) of Congo (Democratic) in 2009 to that in 2010?
Provide a succinct answer. 1.01. What is the ratio of the Total Labor Force (in %) of Ireland in 2009 to that in 2010?
Provide a short and direct response. 1.1. What is the ratio of the Total Labor Force (in %) of Bahamas in 2009 to that in 2011?
Ensure brevity in your answer.  0.99. What is the ratio of the Total Labor Force (in %) in Congo (Democratic) in 2009 to that in 2011?
Your answer should be very brief. 1.01. What is the ratio of the Total Labor Force (in %) in Egypt, Arab Rep. in 2009 to that in 2011?
Give a very brief answer. 0.99. What is the ratio of the Total Labor Force (in %) of Ireland in 2009 to that in 2011?
Give a very brief answer. 1.15. What is the ratio of the Total Labor Force (in %) of Bahamas in 2009 to that in 2012?
Provide a short and direct response. 0.98. What is the ratio of the Total Labor Force (in %) of Congo (Democratic) in 2009 to that in 2012?
Your answer should be very brief. 1.01. What is the ratio of the Total Labor Force (in %) in Egypt, Arab Rep. in 2009 to that in 2012?
Provide a short and direct response. 0.99. What is the ratio of the Total Labor Force (in %) in Ireland in 2009 to that in 2012?
Make the answer very short. 1.16. What is the ratio of the Total Labor Force (in %) in Bahamas in 2009 to that in 2013?
Your answer should be compact. 0.97. What is the ratio of the Total Labor Force (in %) of Congo (Democratic) in 2009 to that in 2013?
Offer a very short reply. 1.02. What is the ratio of the Total Labor Force (in %) of Egypt, Arab Rep. in 2009 to that in 2013?
Your response must be concise. 0.99. What is the ratio of the Total Labor Force (in %) of Ireland in 2009 to that in 2013?
Your answer should be compact. 1.17. What is the ratio of the Total Labor Force (in %) of Bahamas in 2009 to that in 2014?
Give a very brief answer. 0.96. What is the ratio of the Total Labor Force (in %) of Congo (Democratic) in 2009 to that in 2014?
Make the answer very short. 1.02. What is the ratio of the Total Labor Force (in %) of Egypt, Arab Rep. in 2009 to that in 2014?
Your response must be concise. 0.99. What is the ratio of the Total Labor Force (in %) in Ireland in 2009 to that in 2014?
Offer a very short reply. 1.17. What is the ratio of the Total Labor Force (in %) in Congo (Democratic) in 2010 to that in 2011?
Offer a very short reply. 1. What is the ratio of the Total Labor Force (in %) of Ireland in 2010 to that in 2011?
Your response must be concise. 1.04. What is the ratio of the Total Labor Force (in %) of Bahamas in 2010 to that in 2012?
Your answer should be very brief. 0.98. What is the ratio of the Total Labor Force (in %) in Congo (Democratic) in 2010 to that in 2012?
Provide a succinct answer. 1.01. What is the ratio of the Total Labor Force (in %) in Ireland in 2010 to that in 2012?
Keep it short and to the point. 1.05. What is the ratio of the Total Labor Force (in %) in Bahamas in 2010 to that in 2013?
Ensure brevity in your answer.  0.97. What is the ratio of the Total Labor Force (in %) of Congo (Democratic) in 2010 to that in 2013?
Keep it short and to the point. 1.01. What is the ratio of the Total Labor Force (in %) in Egypt, Arab Rep. in 2010 to that in 2013?
Give a very brief answer. 0.99. What is the ratio of the Total Labor Force (in %) in Ireland in 2010 to that in 2013?
Ensure brevity in your answer.  1.06. What is the ratio of the Total Labor Force (in %) in Bahamas in 2010 to that in 2014?
Keep it short and to the point. 0.96. What is the ratio of the Total Labor Force (in %) of Congo (Democratic) in 2010 to that in 2014?
Provide a short and direct response. 1.02. What is the ratio of the Total Labor Force (in %) in Egypt, Arab Rep. in 2010 to that in 2014?
Keep it short and to the point. 0.99. What is the ratio of the Total Labor Force (in %) in Ireland in 2010 to that in 2014?
Provide a succinct answer. 1.06. What is the ratio of the Total Labor Force (in %) of Congo (Democratic) in 2011 to that in 2012?
Provide a short and direct response. 1. What is the ratio of the Total Labor Force (in %) of Bahamas in 2011 to that in 2013?
Your answer should be very brief. 0.98. What is the ratio of the Total Labor Force (in %) in Congo (Democratic) in 2011 to that in 2013?
Make the answer very short. 1.01. What is the ratio of the Total Labor Force (in %) in Egypt, Arab Rep. in 2011 to that in 2013?
Your response must be concise. 1. What is the ratio of the Total Labor Force (in %) in Ireland in 2011 to that in 2013?
Your answer should be very brief. 1.02. What is the ratio of the Total Labor Force (in %) of Bahamas in 2011 to that in 2014?
Provide a short and direct response. 0.97. What is the ratio of the Total Labor Force (in %) in Congo (Democratic) in 2011 to that in 2014?
Your response must be concise. 1.01. What is the ratio of the Total Labor Force (in %) in Egypt, Arab Rep. in 2011 to that in 2014?
Offer a terse response. 1. What is the ratio of the Total Labor Force (in %) of Ireland in 2011 to that in 2014?
Offer a terse response. 1.02. What is the ratio of the Total Labor Force (in %) in Egypt, Arab Rep. in 2012 to that in 2013?
Keep it short and to the point. 1. What is the ratio of the Total Labor Force (in %) of Ireland in 2012 to that in 2013?
Your answer should be very brief. 1.01. What is the ratio of the Total Labor Force (in %) in Bahamas in 2012 to that in 2014?
Ensure brevity in your answer.  0.98. What is the ratio of the Total Labor Force (in %) in Congo (Democratic) in 2012 to that in 2014?
Your response must be concise. 1.01. What is the ratio of the Total Labor Force (in %) in Egypt, Arab Rep. in 2012 to that in 2014?
Offer a terse response. 1. What is the difference between the highest and the second highest Total Labor Force (in %) of Bahamas?
Provide a succinct answer. 0.6. What is the difference between the highest and the lowest Total Labor Force (in %) in Bahamas?
Provide a short and direct response. 2.7. What is the difference between the highest and the lowest Total Labor Force (in %) of Egypt, Arab Rep.?
Keep it short and to the point. 0.8. What is the difference between the highest and the lowest Total Labor Force (in %) of Ireland?
Provide a succinct answer. 12.3. 